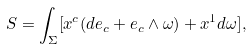<formula> <loc_0><loc_0><loc_500><loc_500>S = \int _ { \Sigma } [ x ^ { c } ( d e _ { c } + e _ { c } \wedge \omega ) + x ^ { 1 } d \omega ] ,</formula> 